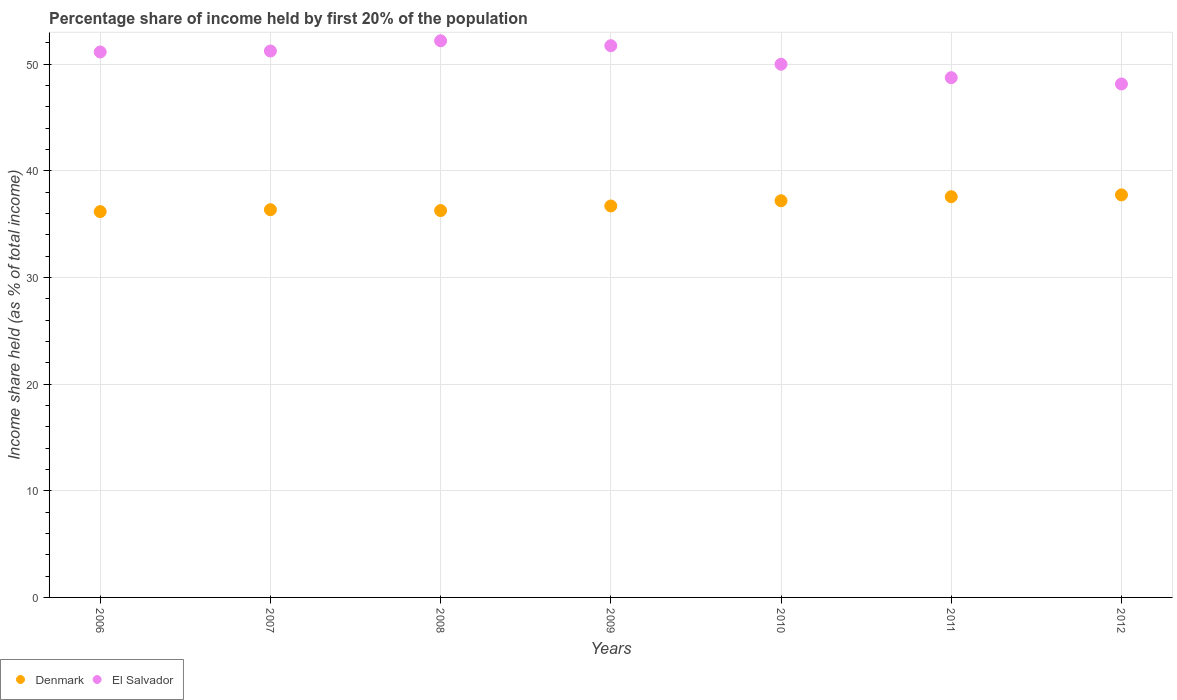What is the share of income held by first 20% of the population in Denmark in 2009?
Ensure brevity in your answer.  36.71. Across all years, what is the maximum share of income held by first 20% of the population in Denmark?
Keep it short and to the point. 37.75. Across all years, what is the minimum share of income held by first 20% of the population in Denmark?
Offer a very short reply. 36.18. What is the total share of income held by first 20% of the population in El Salvador in the graph?
Offer a terse response. 353.22. What is the difference between the share of income held by first 20% of the population in El Salvador in 2009 and that in 2012?
Offer a very short reply. 3.59. What is the difference between the share of income held by first 20% of the population in El Salvador in 2009 and the share of income held by first 20% of the population in Denmark in 2007?
Make the answer very short. 15.38. What is the average share of income held by first 20% of the population in Denmark per year?
Keep it short and to the point. 36.87. In the year 2010, what is the difference between the share of income held by first 20% of the population in El Salvador and share of income held by first 20% of the population in Denmark?
Ensure brevity in your answer.  12.8. In how many years, is the share of income held by first 20% of the population in Denmark greater than 38 %?
Give a very brief answer. 0. What is the ratio of the share of income held by first 20% of the population in El Salvador in 2008 to that in 2012?
Make the answer very short. 1.08. Is the share of income held by first 20% of the population in El Salvador in 2006 less than that in 2007?
Provide a short and direct response. Yes. Is the difference between the share of income held by first 20% of the population in El Salvador in 2011 and 2012 greater than the difference between the share of income held by first 20% of the population in Denmark in 2011 and 2012?
Provide a succinct answer. Yes. What is the difference between the highest and the second highest share of income held by first 20% of the population in El Salvador?
Provide a short and direct response. 0.46. What is the difference between the highest and the lowest share of income held by first 20% of the population in El Salvador?
Offer a terse response. 4.05. In how many years, is the share of income held by first 20% of the population in El Salvador greater than the average share of income held by first 20% of the population in El Salvador taken over all years?
Provide a short and direct response. 4. Is the share of income held by first 20% of the population in Denmark strictly greater than the share of income held by first 20% of the population in El Salvador over the years?
Your response must be concise. No. What is the difference between two consecutive major ticks on the Y-axis?
Your answer should be very brief. 10. Does the graph contain any zero values?
Your answer should be very brief. No. Where does the legend appear in the graph?
Provide a short and direct response. Bottom left. How many legend labels are there?
Provide a succinct answer. 2. What is the title of the graph?
Make the answer very short. Percentage share of income held by first 20% of the population. Does "Mali" appear as one of the legend labels in the graph?
Offer a terse response. No. What is the label or title of the Y-axis?
Offer a terse response. Income share held (as % of total income). What is the Income share held (as % of total income) of Denmark in 2006?
Provide a short and direct response. 36.18. What is the Income share held (as % of total income) in El Salvador in 2006?
Provide a succinct answer. 51.15. What is the Income share held (as % of total income) of Denmark in 2007?
Give a very brief answer. 36.36. What is the Income share held (as % of total income) of El Salvador in 2007?
Offer a terse response. 51.24. What is the Income share held (as % of total income) in Denmark in 2008?
Keep it short and to the point. 36.28. What is the Income share held (as % of total income) in El Salvador in 2008?
Ensure brevity in your answer.  52.2. What is the Income share held (as % of total income) of Denmark in 2009?
Keep it short and to the point. 36.71. What is the Income share held (as % of total income) of El Salvador in 2009?
Provide a succinct answer. 51.74. What is the Income share held (as % of total income) in Denmark in 2010?
Keep it short and to the point. 37.2. What is the Income share held (as % of total income) in Denmark in 2011?
Offer a terse response. 37.58. What is the Income share held (as % of total income) in El Salvador in 2011?
Offer a very short reply. 48.74. What is the Income share held (as % of total income) of Denmark in 2012?
Your answer should be very brief. 37.75. What is the Income share held (as % of total income) of El Salvador in 2012?
Offer a very short reply. 48.15. Across all years, what is the maximum Income share held (as % of total income) of Denmark?
Your response must be concise. 37.75. Across all years, what is the maximum Income share held (as % of total income) in El Salvador?
Keep it short and to the point. 52.2. Across all years, what is the minimum Income share held (as % of total income) in Denmark?
Make the answer very short. 36.18. Across all years, what is the minimum Income share held (as % of total income) in El Salvador?
Offer a terse response. 48.15. What is the total Income share held (as % of total income) in Denmark in the graph?
Make the answer very short. 258.06. What is the total Income share held (as % of total income) of El Salvador in the graph?
Make the answer very short. 353.22. What is the difference between the Income share held (as % of total income) of Denmark in 2006 and that in 2007?
Offer a very short reply. -0.18. What is the difference between the Income share held (as % of total income) of El Salvador in 2006 and that in 2007?
Your response must be concise. -0.09. What is the difference between the Income share held (as % of total income) of El Salvador in 2006 and that in 2008?
Your answer should be compact. -1.05. What is the difference between the Income share held (as % of total income) of Denmark in 2006 and that in 2009?
Your answer should be very brief. -0.53. What is the difference between the Income share held (as % of total income) in El Salvador in 2006 and that in 2009?
Give a very brief answer. -0.59. What is the difference between the Income share held (as % of total income) of Denmark in 2006 and that in 2010?
Provide a succinct answer. -1.02. What is the difference between the Income share held (as % of total income) in El Salvador in 2006 and that in 2010?
Your answer should be compact. 1.15. What is the difference between the Income share held (as % of total income) of El Salvador in 2006 and that in 2011?
Provide a succinct answer. 2.41. What is the difference between the Income share held (as % of total income) of Denmark in 2006 and that in 2012?
Make the answer very short. -1.57. What is the difference between the Income share held (as % of total income) of El Salvador in 2006 and that in 2012?
Provide a short and direct response. 3. What is the difference between the Income share held (as % of total income) of Denmark in 2007 and that in 2008?
Ensure brevity in your answer.  0.08. What is the difference between the Income share held (as % of total income) of El Salvador in 2007 and that in 2008?
Your answer should be compact. -0.96. What is the difference between the Income share held (as % of total income) of Denmark in 2007 and that in 2009?
Your response must be concise. -0.35. What is the difference between the Income share held (as % of total income) in Denmark in 2007 and that in 2010?
Offer a terse response. -0.84. What is the difference between the Income share held (as % of total income) of El Salvador in 2007 and that in 2010?
Keep it short and to the point. 1.24. What is the difference between the Income share held (as % of total income) in Denmark in 2007 and that in 2011?
Provide a succinct answer. -1.22. What is the difference between the Income share held (as % of total income) of El Salvador in 2007 and that in 2011?
Offer a terse response. 2.5. What is the difference between the Income share held (as % of total income) of Denmark in 2007 and that in 2012?
Provide a short and direct response. -1.39. What is the difference between the Income share held (as % of total income) of El Salvador in 2007 and that in 2012?
Ensure brevity in your answer.  3.09. What is the difference between the Income share held (as % of total income) of Denmark in 2008 and that in 2009?
Your answer should be compact. -0.43. What is the difference between the Income share held (as % of total income) of El Salvador in 2008 and that in 2009?
Provide a succinct answer. 0.46. What is the difference between the Income share held (as % of total income) in Denmark in 2008 and that in 2010?
Offer a very short reply. -0.92. What is the difference between the Income share held (as % of total income) of Denmark in 2008 and that in 2011?
Provide a succinct answer. -1.3. What is the difference between the Income share held (as % of total income) in El Salvador in 2008 and that in 2011?
Provide a short and direct response. 3.46. What is the difference between the Income share held (as % of total income) of Denmark in 2008 and that in 2012?
Provide a succinct answer. -1.47. What is the difference between the Income share held (as % of total income) in El Salvador in 2008 and that in 2012?
Your answer should be very brief. 4.05. What is the difference between the Income share held (as % of total income) of Denmark in 2009 and that in 2010?
Your answer should be very brief. -0.49. What is the difference between the Income share held (as % of total income) in El Salvador in 2009 and that in 2010?
Ensure brevity in your answer.  1.74. What is the difference between the Income share held (as % of total income) of Denmark in 2009 and that in 2011?
Provide a short and direct response. -0.87. What is the difference between the Income share held (as % of total income) of El Salvador in 2009 and that in 2011?
Your response must be concise. 3. What is the difference between the Income share held (as % of total income) in Denmark in 2009 and that in 2012?
Your response must be concise. -1.04. What is the difference between the Income share held (as % of total income) of El Salvador in 2009 and that in 2012?
Your response must be concise. 3.59. What is the difference between the Income share held (as % of total income) of Denmark in 2010 and that in 2011?
Ensure brevity in your answer.  -0.38. What is the difference between the Income share held (as % of total income) in El Salvador in 2010 and that in 2011?
Give a very brief answer. 1.26. What is the difference between the Income share held (as % of total income) of Denmark in 2010 and that in 2012?
Provide a succinct answer. -0.55. What is the difference between the Income share held (as % of total income) in El Salvador in 2010 and that in 2012?
Ensure brevity in your answer.  1.85. What is the difference between the Income share held (as % of total income) in Denmark in 2011 and that in 2012?
Offer a very short reply. -0.17. What is the difference between the Income share held (as % of total income) of El Salvador in 2011 and that in 2012?
Ensure brevity in your answer.  0.59. What is the difference between the Income share held (as % of total income) of Denmark in 2006 and the Income share held (as % of total income) of El Salvador in 2007?
Ensure brevity in your answer.  -15.06. What is the difference between the Income share held (as % of total income) of Denmark in 2006 and the Income share held (as % of total income) of El Salvador in 2008?
Your answer should be very brief. -16.02. What is the difference between the Income share held (as % of total income) in Denmark in 2006 and the Income share held (as % of total income) in El Salvador in 2009?
Offer a terse response. -15.56. What is the difference between the Income share held (as % of total income) in Denmark in 2006 and the Income share held (as % of total income) in El Salvador in 2010?
Your answer should be very brief. -13.82. What is the difference between the Income share held (as % of total income) in Denmark in 2006 and the Income share held (as % of total income) in El Salvador in 2011?
Offer a terse response. -12.56. What is the difference between the Income share held (as % of total income) in Denmark in 2006 and the Income share held (as % of total income) in El Salvador in 2012?
Provide a short and direct response. -11.97. What is the difference between the Income share held (as % of total income) in Denmark in 2007 and the Income share held (as % of total income) in El Salvador in 2008?
Make the answer very short. -15.84. What is the difference between the Income share held (as % of total income) in Denmark in 2007 and the Income share held (as % of total income) in El Salvador in 2009?
Make the answer very short. -15.38. What is the difference between the Income share held (as % of total income) of Denmark in 2007 and the Income share held (as % of total income) of El Salvador in 2010?
Provide a succinct answer. -13.64. What is the difference between the Income share held (as % of total income) of Denmark in 2007 and the Income share held (as % of total income) of El Salvador in 2011?
Your answer should be compact. -12.38. What is the difference between the Income share held (as % of total income) in Denmark in 2007 and the Income share held (as % of total income) in El Salvador in 2012?
Your answer should be compact. -11.79. What is the difference between the Income share held (as % of total income) in Denmark in 2008 and the Income share held (as % of total income) in El Salvador in 2009?
Offer a terse response. -15.46. What is the difference between the Income share held (as % of total income) in Denmark in 2008 and the Income share held (as % of total income) in El Salvador in 2010?
Provide a short and direct response. -13.72. What is the difference between the Income share held (as % of total income) of Denmark in 2008 and the Income share held (as % of total income) of El Salvador in 2011?
Provide a short and direct response. -12.46. What is the difference between the Income share held (as % of total income) of Denmark in 2008 and the Income share held (as % of total income) of El Salvador in 2012?
Offer a terse response. -11.87. What is the difference between the Income share held (as % of total income) of Denmark in 2009 and the Income share held (as % of total income) of El Salvador in 2010?
Give a very brief answer. -13.29. What is the difference between the Income share held (as % of total income) in Denmark in 2009 and the Income share held (as % of total income) in El Salvador in 2011?
Make the answer very short. -12.03. What is the difference between the Income share held (as % of total income) in Denmark in 2009 and the Income share held (as % of total income) in El Salvador in 2012?
Your response must be concise. -11.44. What is the difference between the Income share held (as % of total income) of Denmark in 2010 and the Income share held (as % of total income) of El Salvador in 2011?
Your answer should be compact. -11.54. What is the difference between the Income share held (as % of total income) in Denmark in 2010 and the Income share held (as % of total income) in El Salvador in 2012?
Make the answer very short. -10.95. What is the difference between the Income share held (as % of total income) of Denmark in 2011 and the Income share held (as % of total income) of El Salvador in 2012?
Offer a terse response. -10.57. What is the average Income share held (as % of total income) of Denmark per year?
Keep it short and to the point. 36.87. What is the average Income share held (as % of total income) in El Salvador per year?
Ensure brevity in your answer.  50.46. In the year 2006, what is the difference between the Income share held (as % of total income) of Denmark and Income share held (as % of total income) of El Salvador?
Offer a terse response. -14.97. In the year 2007, what is the difference between the Income share held (as % of total income) of Denmark and Income share held (as % of total income) of El Salvador?
Make the answer very short. -14.88. In the year 2008, what is the difference between the Income share held (as % of total income) in Denmark and Income share held (as % of total income) in El Salvador?
Your answer should be very brief. -15.92. In the year 2009, what is the difference between the Income share held (as % of total income) in Denmark and Income share held (as % of total income) in El Salvador?
Provide a succinct answer. -15.03. In the year 2011, what is the difference between the Income share held (as % of total income) of Denmark and Income share held (as % of total income) of El Salvador?
Give a very brief answer. -11.16. What is the ratio of the Income share held (as % of total income) in El Salvador in 2006 to that in 2008?
Make the answer very short. 0.98. What is the ratio of the Income share held (as % of total income) in Denmark in 2006 to that in 2009?
Provide a short and direct response. 0.99. What is the ratio of the Income share held (as % of total income) of El Salvador in 2006 to that in 2009?
Your answer should be compact. 0.99. What is the ratio of the Income share held (as % of total income) of Denmark in 2006 to that in 2010?
Make the answer very short. 0.97. What is the ratio of the Income share held (as % of total income) of El Salvador in 2006 to that in 2010?
Your answer should be compact. 1.02. What is the ratio of the Income share held (as % of total income) in Denmark in 2006 to that in 2011?
Give a very brief answer. 0.96. What is the ratio of the Income share held (as % of total income) of El Salvador in 2006 to that in 2011?
Give a very brief answer. 1.05. What is the ratio of the Income share held (as % of total income) of Denmark in 2006 to that in 2012?
Provide a succinct answer. 0.96. What is the ratio of the Income share held (as % of total income) in El Salvador in 2006 to that in 2012?
Your answer should be very brief. 1.06. What is the ratio of the Income share held (as % of total income) of Denmark in 2007 to that in 2008?
Offer a terse response. 1. What is the ratio of the Income share held (as % of total income) in El Salvador in 2007 to that in 2008?
Make the answer very short. 0.98. What is the ratio of the Income share held (as % of total income) of Denmark in 2007 to that in 2009?
Ensure brevity in your answer.  0.99. What is the ratio of the Income share held (as % of total income) in El Salvador in 2007 to that in 2009?
Your response must be concise. 0.99. What is the ratio of the Income share held (as % of total income) in Denmark in 2007 to that in 2010?
Offer a terse response. 0.98. What is the ratio of the Income share held (as % of total income) of El Salvador in 2007 to that in 2010?
Your answer should be compact. 1.02. What is the ratio of the Income share held (as % of total income) in Denmark in 2007 to that in 2011?
Give a very brief answer. 0.97. What is the ratio of the Income share held (as % of total income) in El Salvador in 2007 to that in 2011?
Provide a succinct answer. 1.05. What is the ratio of the Income share held (as % of total income) of Denmark in 2007 to that in 2012?
Offer a very short reply. 0.96. What is the ratio of the Income share held (as % of total income) in El Salvador in 2007 to that in 2012?
Ensure brevity in your answer.  1.06. What is the ratio of the Income share held (as % of total income) in Denmark in 2008 to that in 2009?
Provide a short and direct response. 0.99. What is the ratio of the Income share held (as % of total income) of El Salvador in 2008 to that in 2009?
Offer a terse response. 1.01. What is the ratio of the Income share held (as % of total income) of Denmark in 2008 to that in 2010?
Your answer should be very brief. 0.98. What is the ratio of the Income share held (as % of total income) of El Salvador in 2008 to that in 2010?
Your answer should be very brief. 1.04. What is the ratio of the Income share held (as % of total income) in Denmark in 2008 to that in 2011?
Your response must be concise. 0.97. What is the ratio of the Income share held (as % of total income) of El Salvador in 2008 to that in 2011?
Offer a very short reply. 1.07. What is the ratio of the Income share held (as % of total income) of Denmark in 2008 to that in 2012?
Offer a terse response. 0.96. What is the ratio of the Income share held (as % of total income) in El Salvador in 2008 to that in 2012?
Give a very brief answer. 1.08. What is the ratio of the Income share held (as % of total income) in El Salvador in 2009 to that in 2010?
Your response must be concise. 1.03. What is the ratio of the Income share held (as % of total income) of Denmark in 2009 to that in 2011?
Ensure brevity in your answer.  0.98. What is the ratio of the Income share held (as % of total income) of El Salvador in 2009 to that in 2011?
Make the answer very short. 1.06. What is the ratio of the Income share held (as % of total income) in Denmark in 2009 to that in 2012?
Offer a terse response. 0.97. What is the ratio of the Income share held (as % of total income) of El Salvador in 2009 to that in 2012?
Give a very brief answer. 1.07. What is the ratio of the Income share held (as % of total income) of El Salvador in 2010 to that in 2011?
Your answer should be very brief. 1.03. What is the ratio of the Income share held (as % of total income) in Denmark in 2010 to that in 2012?
Your answer should be very brief. 0.99. What is the ratio of the Income share held (as % of total income) of El Salvador in 2010 to that in 2012?
Your answer should be very brief. 1.04. What is the ratio of the Income share held (as % of total income) of Denmark in 2011 to that in 2012?
Provide a short and direct response. 1. What is the ratio of the Income share held (as % of total income) in El Salvador in 2011 to that in 2012?
Make the answer very short. 1.01. What is the difference between the highest and the second highest Income share held (as % of total income) of Denmark?
Offer a very short reply. 0.17. What is the difference between the highest and the second highest Income share held (as % of total income) in El Salvador?
Provide a short and direct response. 0.46. What is the difference between the highest and the lowest Income share held (as % of total income) of Denmark?
Offer a very short reply. 1.57. What is the difference between the highest and the lowest Income share held (as % of total income) of El Salvador?
Your response must be concise. 4.05. 